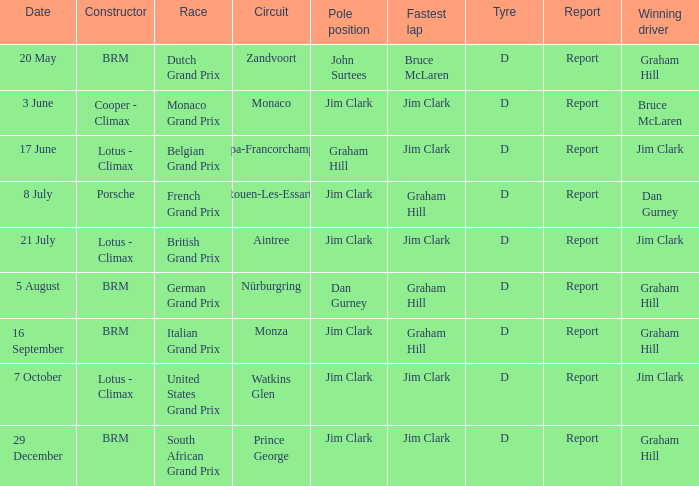What is the constructor at the United States Grand Prix? Lotus - Climax. 